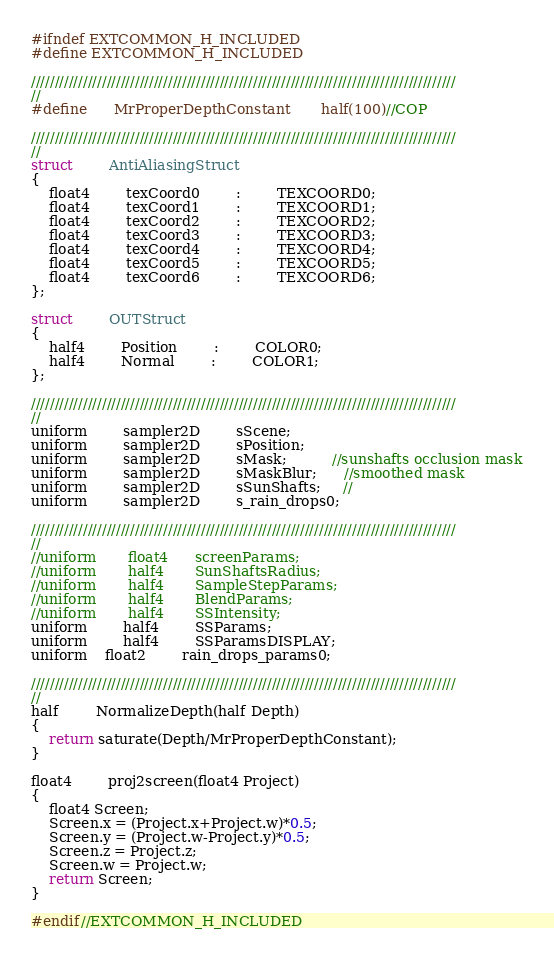Convert code to text. <code><loc_0><loc_0><loc_500><loc_500><_C_>#ifndef EXTCOMMON_H_INCLUDED
#define EXTCOMMON_H_INCLUDED

//////////////////////////////////////////////////////////////////////////////////////////
//
#define		MrProperDepthConstant		half(100)//COP

//////////////////////////////////////////////////////////////////////////////////////////
//
struct		AntiAliasingStruct
{
	float4		texCoord0		:		TEXCOORD0;
	float4		texCoord1		:		TEXCOORD1;
	float4		texCoord2		:		TEXCOORD2;
	float4		texCoord3		:		TEXCOORD3;
	float4		texCoord4		:		TEXCOORD4;
	float4		texCoord5		:		TEXCOORD5;
	float4		texCoord6		:		TEXCOORD6;
};

struct		OUTStruct
{
	half4		Position		:		COLOR0;
	half4		Normal		:		COLOR1;
};

//////////////////////////////////////////////////////////////////////////////////////////
//
uniform		sampler2D		sScene;
uniform		sampler2D		sPosition;
uniform		sampler2D		sMask;          //sunshafts occlusion mask
uniform		sampler2D		sMaskBlur;      //smoothed mask
uniform		sampler2D		sSunShafts;     //
uniform		sampler2D		s_rain_drops0;

//////////////////////////////////////////////////////////////////////////////////////////
//
//uniform		float4		screenParams;
//uniform		half4		SunShaftsRadius;
//uniform		half4		SampleStepParams;
//uniform		half4		BlendParams;
//uniform		half4		SSIntensity;
uniform		half4		SSParams;
uniform		half4		SSParamsDISPLAY;
uniform 	float2 		rain_drops_params0;

//////////////////////////////////////////////////////////////////////////////////////////
//
half		NormalizeDepth(half Depth)
{
	return saturate(Depth/MrProperDepthConstant);
}

float4		proj2screen(float4 Project)
{
	float4 Screen;
	Screen.x = (Project.x+Project.w)*0.5;
	Screen.y = (Project.w-Project.y)*0.5;
	Screen.z = Project.z;
	Screen.w = Project.w;
	return Screen;
}

#endif//EXTCOMMON_H_INCLUDED</code> 